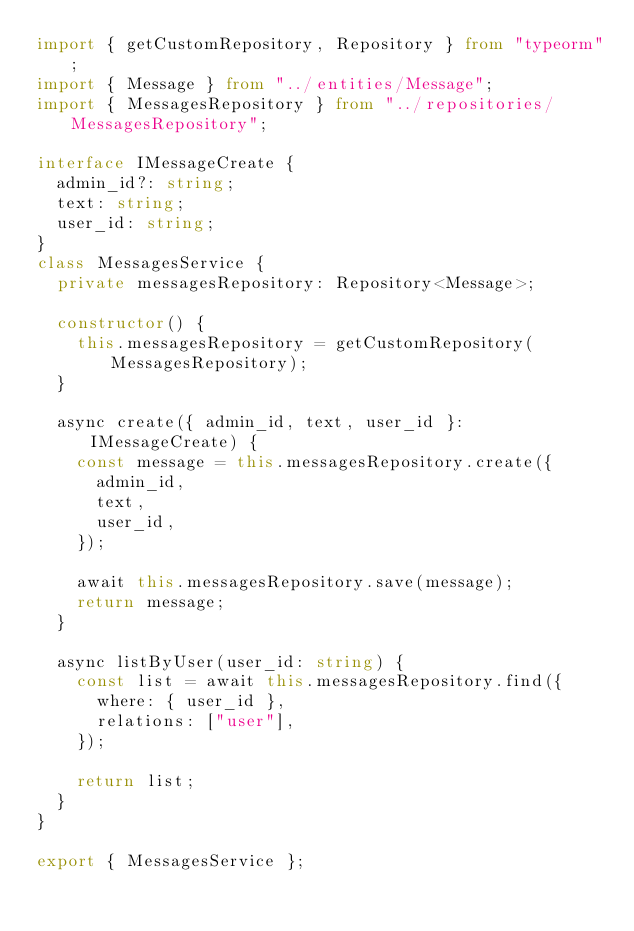Convert code to text. <code><loc_0><loc_0><loc_500><loc_500><_TypeScript_>import { getCustomRepository, Repository } from "typeorm";
import { Message } from "../entities/Message";
import { MessagesRepository } from "../repositories/MessagesRepository";

interface IMessageCreate {
  admin_id?: string;
  text: string;
  user_id: string;
}
class MessagesService {
  private messagesRepository: Repository<Message>;

  constructor() {
    this.messagesRepository = getCustomRepository(MessagesRepository);
  }

  async create({ admin_id, text, user_id }: IMessageCreate) {
    const message = this.messagesRepository.create({
      admin_id,
      text,
      user_id,
    });

    await this.messagesRepository.save(message);
    return message;
  }

  async listByUser(user_id: string) {
    const list = await this.messagesRepository.find({
      where: { user_id },
      relations: ["user"],
    });

    return list;
  }
}

export { MessagesService };
</code> 